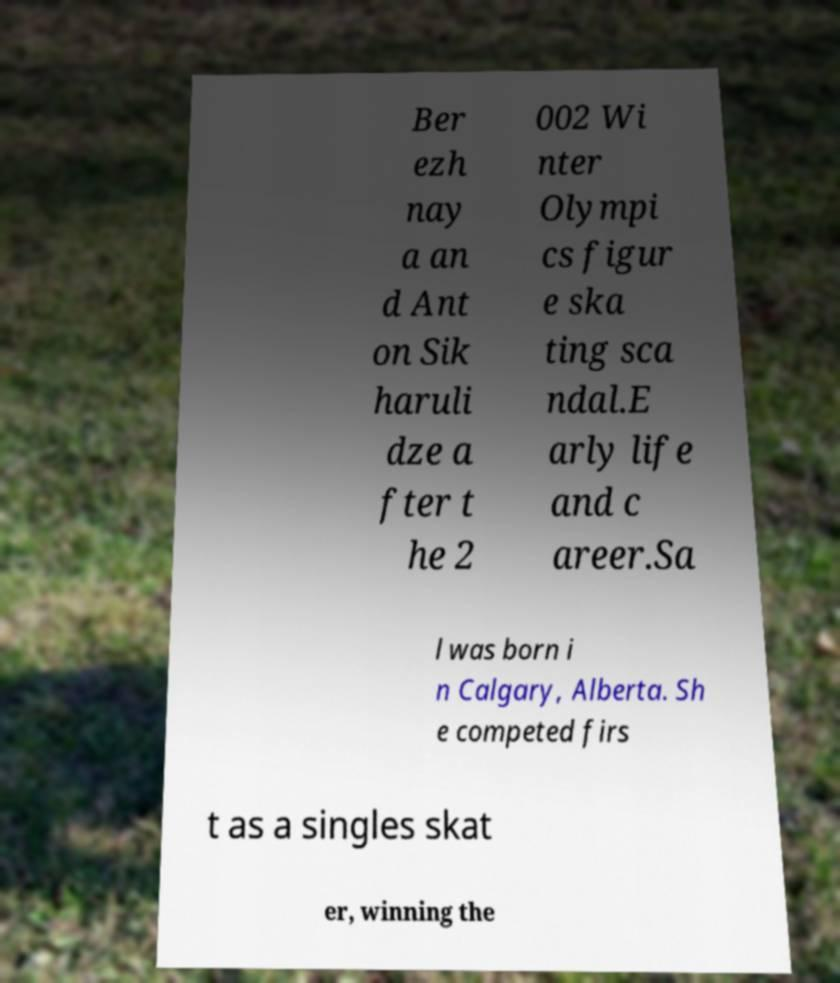There's text embedded in this image that I need extracted. Can you transcribe it verbatim? Ber ezh nay a an d Ant on Sik haruli dze a fter t he 2 002 Wi nter Olympi cs figur e ska ting sca ndal.E arly life and c areer.Sa l was born i n Calgary, Alberta. Sh e competed firs t as a singles skat er, winning the 